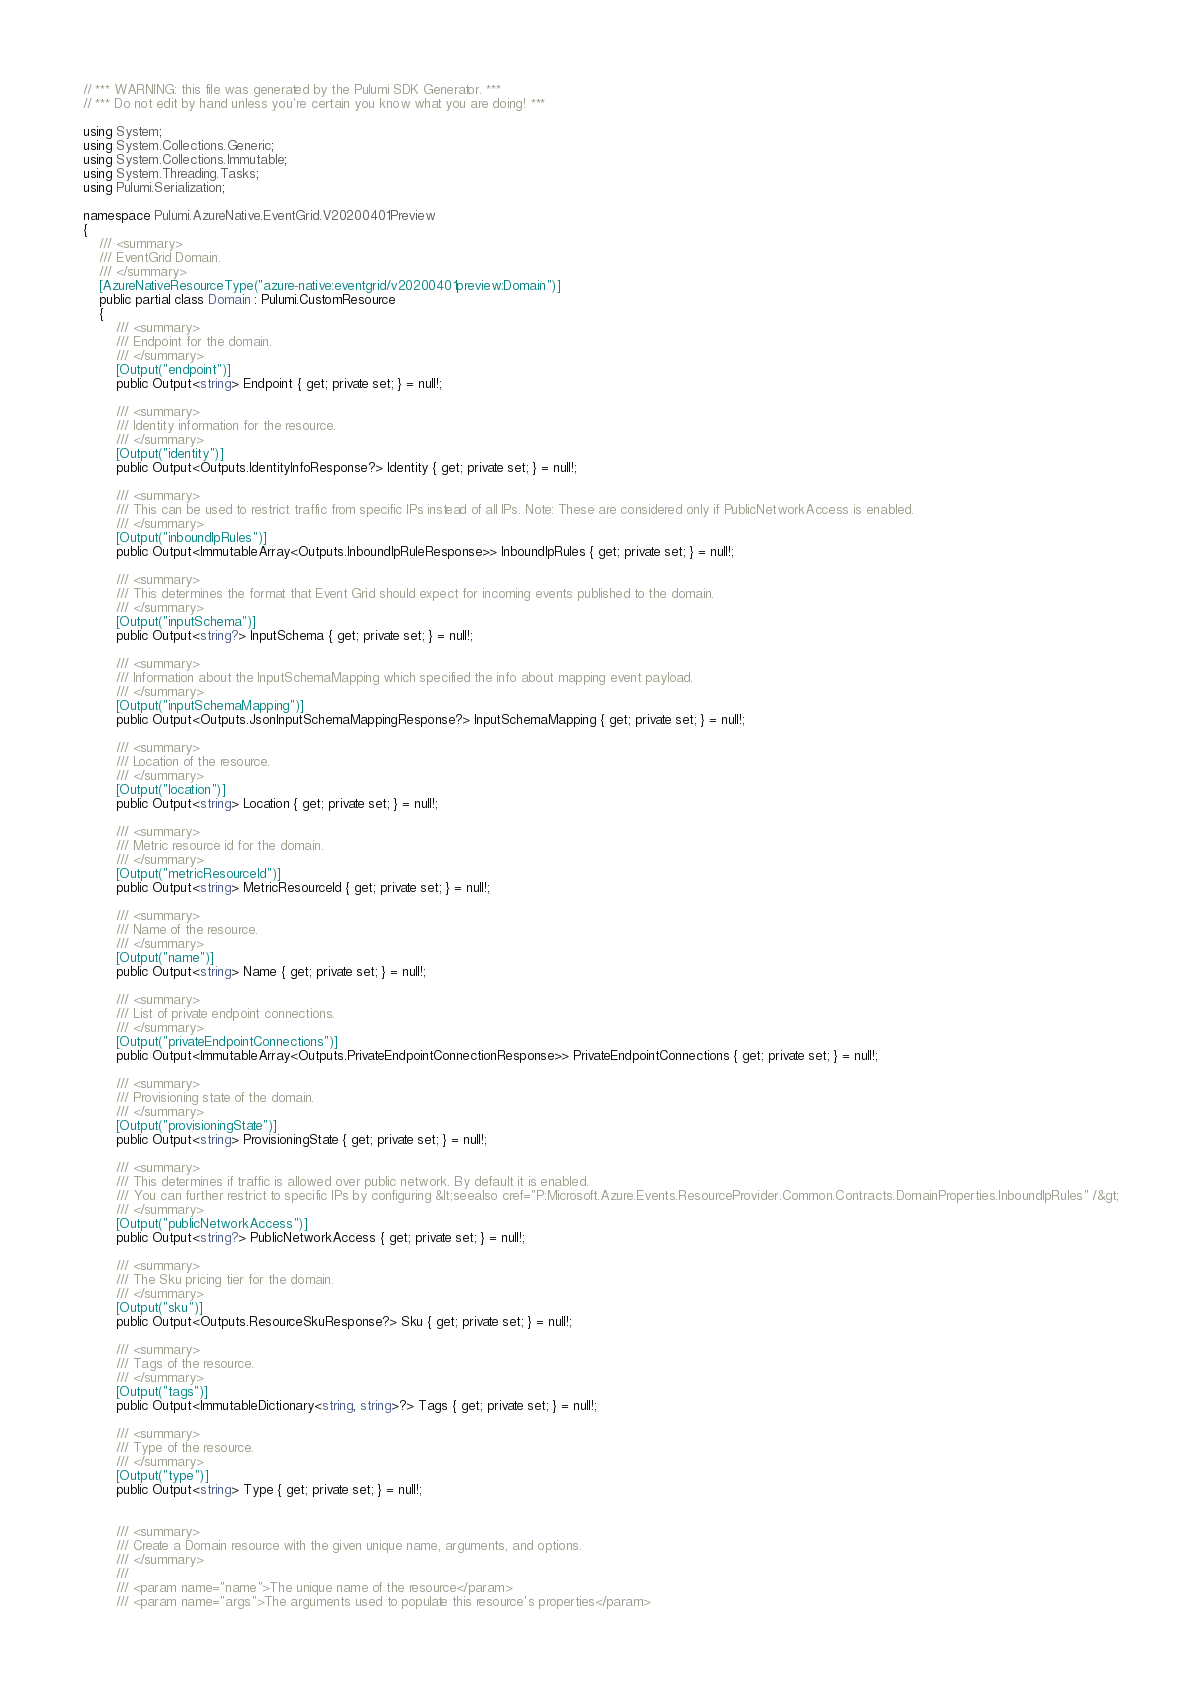Convert code to text. <code><loc_0><loc_0><loc_500><loc_500><_C#_>// *** WARNING: this file was generated by the Pulumi SDK Generator. ***
// *** Do not edit by hand unless you're certain you know what you are doing! ***

using System;
using System.Collections.Generic;
using System.Collections.Immutable;
using System.Threading.Tasks;
using Pulumi.Serialization;

namespace Pulumi.AzureNative.EventGrid.V20200401Preview
{
    /// <summary>
    /// EventGrid Domain.
    /// </summary>
    [AzureNativeResourceType("azure-native:eventgrid/v20200401preview:Domain")]
    public partial class Domain : Pulumi.CustomResource
    {
        /// <summary>
        /// Endpoint for the domain.
        /// </summary>
        [Output("endpoint")]
        public Output<string> Endpoint { get; private set; } = null!;

        /// <summary>
        /// Identity information for the resource.
        /// </summary>
        [Output("identity")]
        public Output<Outputs.IdentityInfoResponse?> Identity { get; private set; } = null!;

        /// <summary>
        /// This can be used to restrict traffic from specific IPs instead of all IPs. Note: These are considered only if PublicNetworkAccess is enabled.
        /// </summary>
        [Output("inboundIpRules")]
        public Output<ImmutableArray<Outputs.InboundIpRuleResponse>> InboundIpRules { get; private set; } = null!;

        /// <summary>
        /// This determines the format that Event Grid should expect for incoming events published to the domain.
        /// </summary>
        [Output("inputSchema")]
        public Output<string?> InputSchema { get; private set; } = null!;

        /// <summary>
        /// Information about the InputSchemaMapping which specified the info about mapping event payload.
        /// </summary>
        [Output("inputSchemaMapping")]
        public Output<Outputs.JsonInputSchemaMappingResponse?> InputSchemaMapping { get; private set; } = null!;

        /// <summary>
        /// Location of the resource.
        /// </summary>
        [Output("location")]
        public Output<string> Location { get; private set; } = null!;

        /// <summary>
        /// Metric resource id for the domain.
        /// </summary>
        [Output("metricResourceId")]
        public Output<string> MetricResourceId { get; private set; } = null!;

        /// <summary>
        /// Name of the resource.
        /// </summary>
        [Output("name")]
        public Output<string> Name { get; private set; } = null!;

        /// <summary>
        /// List of private endpoint connections.
        /// </summary>
        [Output("privateEndpointConnections")]
        public Output<ImmutableArray<Outputs.PrivateEndpointConnectionResponse>> PrivateEndpointConnections { get; private set; } = null!;

        /// <summary>
        /// Provisioning state of the domain.
        /// </summary>
        [Output("provisioningState")]
        public Output<string> ProvisioningState { get; private set; } = null!;

        /// <summary>
        /// This determines if traffic is allowed over public network. By default it is enabled. 
        /// You can further restrict to specific IPs by configuring &lt;seealso cref="P:Microsoft.Azure.Events.ResourceProvider.Common.Contracts.DomainProperties.InboundIpRules" /&gt;
        /// </summary>
        [Output("publicNetworkAccess")]
        public Output<string?> PublicNetworkAccess { get; private set; } = null!;

        /// <summary>
        /// The Sku pricing tier for the domain.
        /// </summary>
        [Output("sku")]
        public Output<Outputs.ResourceSkuResponse?> Sku { get; private set; } = null!;

        /// <summary>
        /// Tags of the resource.
        /// </summary>
        [Output("tags")]
        public Output<ImmutableDictionary<string, string>?> Tags { get; private set; } = null!;

        /// <summary>
        /// Type of the resource.
        /// </summary>
        [Output("type")]
        public Output<string> Type { get; private set; } = null!;


        /// <summary>
        /// Create a Domain resource with the given unique name, arguments, and options.
        /// </summary>
        ///
        /// <param name="name">The unique name of the resource</param>
        /// <param name="args">The arguments used to populate this resource's properties</param></code> 